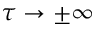Convert formula to latex. <formula><loc_0><loc_0><loc_500><loc_500>\tau \to \pm \infty</formula> 